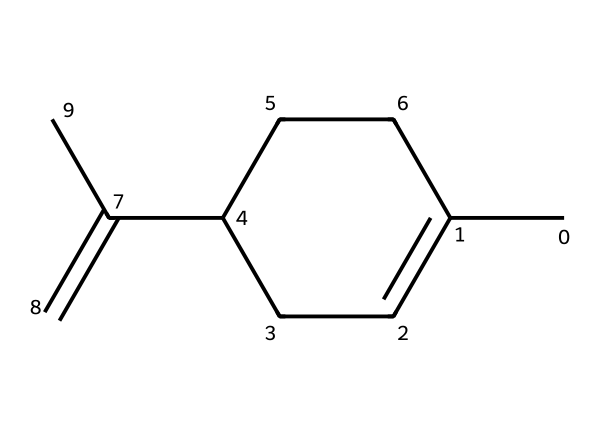What is the total number of carbon atoms in limonene? By analyzing the SMILES representation, we count the number of 'C' symbols. The structure shows 10 carbon atoms in total.
Answer: 10 How many rings are present in the limonene structure? The structure is identified as a cycloalkane, and by examining the SMILES, we can see a single ring that involves the carbon chain.
Answer: 1 What functional group is associated with limonene? Limonene is a terpene, which typically contains a double bond. In the structure, the "=C" indicates the presence of a double bond, characteristic of terpenes.
Answer: double bond What is the degree of saturation for the limonene molecule? The degree of saturation can be calculated by using the formula: Degree of Saturation = (2C + 2 - H) / 2. For limonene with 10 carbons and 16 hydrogens, it results in 3.
Answer: 3 Is limonene a saturated or unsaturated compound? Since the structure shows a double bond, it classifies limonene as an unsaturated hydrocarbon, meaning it contains less than the maximum number of hydrogen atoms for the given number of carbons.
Answer: unsaturated What type of cyclic structure is found in limonene? Limonene is classified as a cycloalkane since it contains a ring structure with single bonds, along with its characteristic branched aliphatic chains.
Answer: cycloalkane 